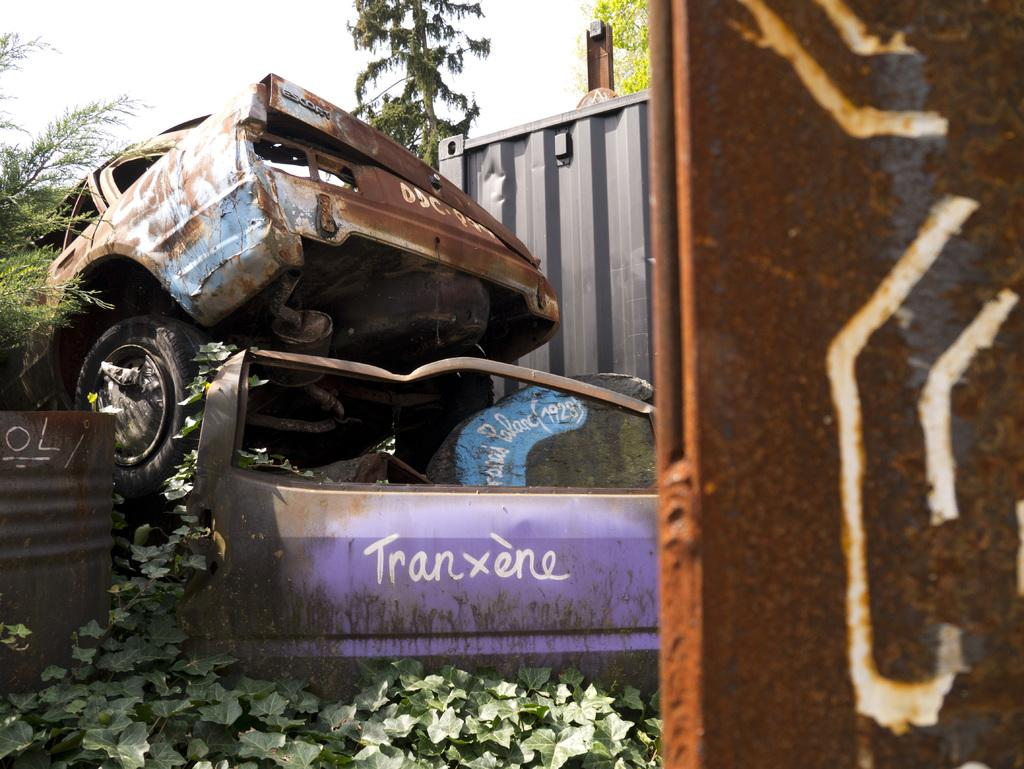What type of vehicles can be seen in the image? There are rusted vehicles in the image. What is growing on the ground in the image? Creepers are present on the ground in the image. What type of vegetation is visible in the image? There are trees visible in the image. What is visible in the background of the image? The sky is visible in the image. What type of stocking is hanging from the tree in the image? There is no stocking hanging from the tree in the image. Can you tell me how many drains are visible in the image? There are no drains visible in the image. 